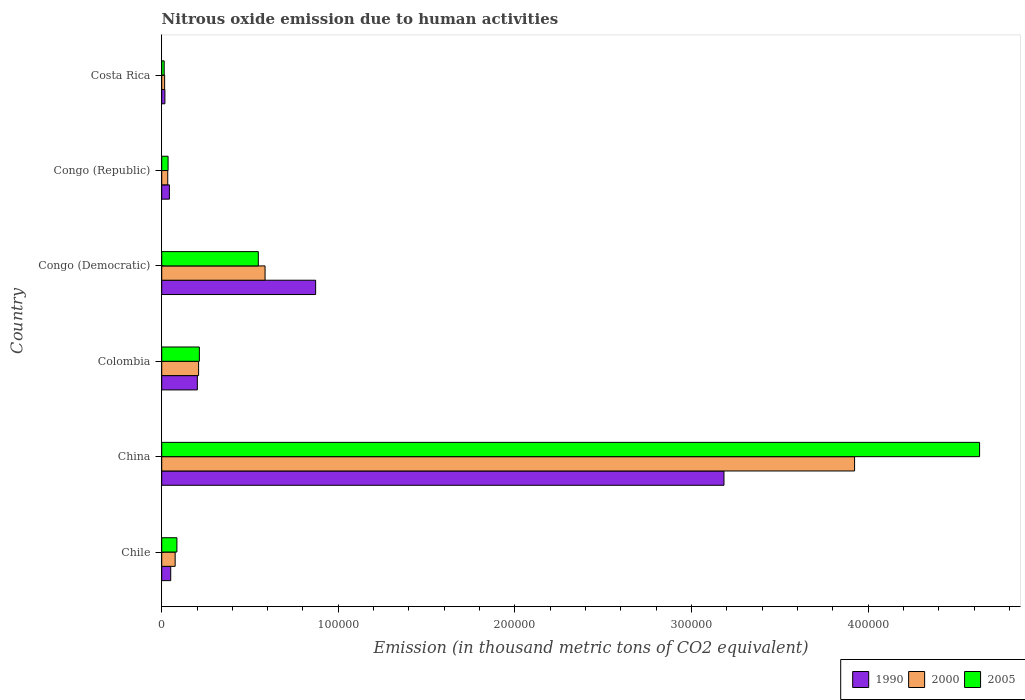How many groups of bars are there?
Make the answer very short. 6. Are the number of bars per tick equal to the number of legend labels?
Offer a very short reply. Yes. Are the number of bars on each tick of the Y-axis equal?
Offer a very short reply. Yes. How many bars are there on the 5th tick from the top?
Ensure brevity in your answer.  3. How many bars are there on the 6th tick from the bottom?
Give a very brief answer. 3. What is the amount of nitrous oxide emitted in 2005 in Colombia?
Your response must be concise. 2.13e+04. Across all countries, what is the maximum amount of nitrous oxide emitted in 1990?
Make the answer very short. 3.18e+05. Across all countries, what is the minimum amount of nitrous oxide emitted in 1990?
Your answer should be very brief. 1812.5. In which country was the amount of nitrous oxide emitted in 1990 maximum?
Give a very brief answer. China. What is the total amount of nitrous oxide emitted in 2000 in the graph?
Provide a succinct answer. 4.84e+05. What is the difference between the amount of nitrous oxide emitted in 2000 in Congo (Democratic) and that in Congo (Republic)?
Your answer should be very brief. 5.51e+04. What is the difference between the amount of nitrous oxide emitted in 1990 in Chile and the amount of nitrous oxide emitted in 2000 in Costa Rica?
Give a very brief answer. 3447.5. What is the average amount of nitrous oxide emitted in 1990 per country?
Make the answer very short. 7.28e+04. What is the difference between the amount of nitrous oxide emitted in 2000 and amount of nitrous oxide emitted in 1990 in Colombia?
Ensure brevity in your answer.  706.7. What is the ratio of the amount of nitrous oxide emitted in 1990 in Colombia to that in Costa Rica?
Offer a terse response. 11.13. Is the difference between the amount of nitrous oxide emitted in 2000 in China and Congo (Republic) greater than the difference between the amount of nitrous oxide emitted in 1990 in China and Congo (Republic)?
Your response must be concise. Yes. What is the difference between the highest and the second highest amount of nitrous oxide emitted in 2005?
Provide a short and direct response. 4.08e+05. What is the difference between the highest and the lowest amount of nitrous oxide emitted in 2000?
Your answer should be very brief. 3.91e+05. In how many countries, is the amount of nitrous oxide emitted in 2000 greater than the average amount of nitrous oxide emitted in 2000 taken over all countries?
Your response must be concise. 1. Is the sum of the amount of nitrous oxide emitted in 2000 in Chile and Congo (Democratic) greater than the maximum amount of nitrous oxide emitted in 1990 across all countries?
Provide a succinct answer. No. Is it the case that in every country, the sum of the amount of nitrous oxide emitted in 2000 and amount of nitrous oxide emitted in 1990 is greater than the amount of nitrous oxide emitted in 2005?
Offer a terse response. Yes. Are the values on the major ticks of X-axis written in scientific E-notation?
Provide a succinct answer. No. Does the graph contain any zero values?
Make the answer very short. No. Does the graph contain grids?
Give a very brief answer. No. How are the legend labels stacked?
Provide a succinct answer. Horizontal. What is the title of the graph?
Your answer should be very brief. Nitrous oxide emission due to human activities. What is the label or title of the X-axis?
Ensure brevity in your answer.  Emission (in thousand metric tons of CO2 equivalent). What is the label or title of the Y-axis?
Keep it short and to the point. Country. What is the Emission (in thousand metric tons of CO2 equivalent) of 1990 in Chile?
Keep it short and to the point. 5100.7. What is the Emission (in thousand metric tons of CO2 equivalent) of 2000 in Chile?
Give a very brief answer. 7617.9. What is the Emission (in thousand metric tons of CO2 equivalent) of 2005 in Chile?
Your answer should be very brief. 8607.6. What is the Emission (in thousand metric tons of CO2 equivalent) in 1990 in China?
Your answer should be compact. 3.18e+05. What is the Emission (in thousand metric tons of CO2 equivalent) in 2000 in China?
Provide a short and direct response. 3.92e+05. What is the Emission (in thousand metric tons of CO2 equivalent) of 2005 in China?
Give a very brief answer. 4.63e+05. What is the Emission (in thousand metric tons of CO2 equivalent) in 1990 in Colombia?
Your answer should be compact. 2.02e+04. What is the Emission (in thousand metric tons of CO2 equivalent) of 2000 in Colombia?
Offer a very short reply. 2.09e+04. What is the Emission (in thousand metric tons of CO2 equivalent) of 2005 in Colombia?
Keep it short and to the point. 2.13e+04. What is the Emission (in thousand metric tons of CO2 equivalent) of 1990 in Congo (Democratic)?
Make the answer very short. 8.72e+04. What is the Emission (in thousand metric tons of CO2 equivalent) of 2000 in Congo (Democratic)?
Offer a very short reply. 5.85e+04. What is the Emission (in thousand metric tons of CO2 equivalent) in 2005 in Congo (Democratic)?
Provide a succinct answer. 5.47e+04. What is the Emission (in thousand metric tons of CO2 equivalent) of 1990 in Congo (Republic)?
Your answer should be compact. 4351.5. What is the Emission (in thousand metric tons of CO2 equivalent) of 2000 in Congo (Republic)?
Your answer should be compact. 3418.3. What is the Emission (in thousand metric tons of CO2 equivalent) in 2005 in Congo (Republic)?
Ensure brevity in your answer.  3603.5. What is the Emission (in thousand metric tons of CO2 equivalent) in 1990 in Costa Rica?
Give a very brief answer. 1812.5. What is the Emission (in thousand metric tons of CO2 equivalent) in 2000 in Costa Rica?
Offer a terse response. 1653.2. What is the Emission (in thousand metric tons of CO2 equivalent) of 2005 in Costa Rica?
Offer a terse response. 1401. Across all countries, what is the maximum Emission (in thousand metric tons of CO2 equivalent) in 1990?
Make the answer very short. 3.18e+05. Across all countries, what is the maximum Emission (in thousand metric tons of CO2 equivalent) of 2000?
Your answer should be compact. 3.92e+05. Across all countries, what is the maximum Emission (in thousand metric tons of CO2 equivalent) in 2005?
Your answer should be compact. 4.63e+05. Across all countries, what is the minimum Emission (in thousand metric tons of CO2 equivalent) of 1990?
Provide a succinct answer. 1812.5. Across all countries, what is the minimum Emission (in thousand metric tons of CO2 equivalent) of 2000?
Your answer should be very brief. 1653.2. Across all countries, what is the minimum Emission (in thousand metric tons of CO2 equivalent) of 2005?
Keep it short and to the point. 1401. What is the total Emission (in thousand metric tons of CO2 equivalent) in 1990 in the graph?
Offer a terse response. 4.37e+05. What is the total Emission (in thousand metric tons of CO2 equivalent) in 2000 in the graph?
Offer a terse response. 4.84e+05. What is the total Emission (in thousand metric tons of CO2 equivalent) in 2005 in the graph?
Your answer should be very brief. 5.53e+05. What is the difference between the Emission (in thousand metric tons of CO2 equivalent) of 1990 in Chile and that in China?
Your answer should be compact. -3.13e+05. What is the difference between the Emission (in thousand metric tons of CO2 equivalent) in 2000 in Chile and that in China?
Give a very brief answer. -3.85e+05. What is the difference between the Emission (in thousand metric tons of CO2 equivalent) of 2005 in Chile and that in China?
Keep it short and to the point. -4.55e+05. What is the difference between the Emission (in thousand metric tons of CO2 equivalent) in 1990 in Chile and that in Colombia?
Offer a very short reply. -1.51e+04. What is the difference between the Emission (in thousand metric tons of CO2 equivalent) in 2000 in Chile and that in Colombia?
Offer a very short reply. -1.33e+04. What is the difference between the Emission (in thousand metric tons of CO2 equivalent) of 2005 in Chile and that in Colombia?
Provide a succinct answer. -1.27e+04. What is the difference between the Emission (in thousand metric tons of CO2 equivalent) of 1990 in Chile and that in Congo (Democratic)?
Ensure brevity in your answer.  -8.21e+04. What is the difference between the Emission (in thousand metric tons of CO2 equivalent) of 2000 in Chile and that in Congo (Democratic)?
Provide a short and direct response. -5.09e+04. What is the difference between the Emission (in thousand metric tons of CO2 equivalent) in 2005 in Chile and that in Congo (Democratic)?
Make the answer very short. -4.61e+04. What is the difference between the Emission (in thousand metric tons of CO2 equivalent) in 1990 in Chile and that in Congo (Republic)?
Provide a short and direct response. 749.2. What is the difference between the Emission (in thousand metric tons of CO2 equivalent) in 2000 in Chile and that in Congo (Republic)?
Offer a terse response. 4199.6. What is the difference between the Emission (in thousand metric tons of CO2 equivalent) of 2005 in Chile and that in Congo (Republic)?
Make the answer very short. 5004.1. What is the difference between the Emission (in thousand metric tons of CO2 equivalent) of 1990 in Chile and that in Costa Rica?
Ensure brevity in your answer.  3288.2. What is the difference between the Emission (in thousand metric tons of CO2 equivalent) of 2000 in Chile and that in Costa Rica?
Give a very brief answer. 5964.7. What is the difference between the Emission (in thousand metric tons of CO2 equivalent) in 2005 in Chile and that in Costa Rica?
Offer a very short reply. 7206.6. What is the difference between the Emission (in thousand metric tons of CO2 equivalent) in 1990 in China and that in Colombia?
Keep it short and to the point. 2.98e+05. What is the difference between the Emission (in thousand metric tons of CO2 equivalent) in 2000 in China and that in Colombia?
Provide a short and direct response. 3.71e+05. What is the difference between the Emission (in thousand metric tons of CO2 equivalent) of 2005 in China and that in Colombia?
Your response must be concise. 4.42e+05. What is the difference between the Emission (in thousand metric tons of CO2 equivalent) in 1990 in China and that in Congo (Democratic)?
Offer a terse response. 2.31e+05. What is the difference between the Emission (in thousand metric tons of CO2 equivalent) of 2000 in China and that in Congo (Democratic)?
Make the answer very short. 3.34e+05. What is the difference between the Emission (in thousand metric tons of CO2 equivalent) of 2005 in China and that in Congo (Democratic)?
Make the answer very short. 4.08e+05. What is the difference between the Emission (in thousand metric tons of CO2 equivalent) in 1990 in China and that in Congo (Republic)?
Provide a short and direct response. 3.14e+05. What is the difference between the Emission (in thousand metric tons of CO2 equivalent) of 2000 in China and that in Congo (Republic)?
Offer a terse response. 3.89e+05. What is the difference between the Emission (in thousand metric tons of CO2 equivalent) in 2005 in China and that in Congo (Republic)?
Offer a very short reply. 4.60e+05. What is the difference between the Emission (in thousand metric tons of CO2 equivalent) in 1990 in China and that in Costa Rica?
Give a very brief answer. 3.17e+05. What is the difference between the Emission (in thousand metric tons of CO2 equivalent) in 2000 in China and that in Costa Rica?
Keep it short and to the point. 3.91e+05. What is the difference between the Emission (in thousand metric tons of CO2 equivalent) in 2005 in China and that in Costa Rica?
Ensure brevity in your answer.  4.62e+05. What is the difference between the Emission (in thousand metric tons of CO2 equivalent) in 1990 in Colombia and that in Congo (Democratic)?
Your answer should be very brief. -6.70e+04. What is the difference between the Emission (in thousand metric tons of CO2 equivalent) of 2000 in Colombia and that in Congo (Democratic)?
Make the answer very short. -3.76e+04. What is the difference between the Emission (in thousand metric tons of CO2 equivalent) of 2005 in Colombia and that in Congo (Democratic)?
Offer a terse response. -3.34e+04. What is the difference between the Emission (in thousand metric tons of CO2 equivalent) in 1990 in Colombia and that in Congo (Republic)?
Keep it short and to the point. 1.58e+04. What is the difference between the Emission (in thousand metric tons of CO2 equivalent) in 2000 in Colombia and that in Congo (Republic)?
Keep it short and to the point. 1.75e+04. What is the difference between the Emission (in thousand metric tons of CO2 equivalent) of 2005 in Colombia and that in Congo (Republic)?
Ensure brevity in your answer.  1.77e+04. What is the difference between the Emission (in thousand metric tons of CO2 equivalent) in 1990 in Colombia and that in Costa Rica?
Keep it short and to the point. 1.84e+04. What is the difference between the Emission (in thousand metric tons of CO2 equivalent) of 2000 in Colombia and that in Costa Rica?
Provide a succinct answer. 1.92e+04. What is the difference between the Emission (in thousand metric tons of CO2 equivalent) of 2005 in Colombia and that in Costa Rica?
Provide a succinct answer. 1.99e+04. What is the difference between the Emission (in thousand metric tons of CO2 equivalent) in 1990 in Congo (Democratic) and that in Congo (Republic)?
Provide a short and direct response. 8.28e+04. What is the difference between the Emission (in thousand metric tons of CO2 equivalent) in 2000 in Congo (Democratic) and that in Congo (Republic)?
Make the answer very short. 5.51e+04. What is the difference between the Emission (in thousand metric tons of CO2 equivalent) of 2005 in Congo (Democratic) and that in Congo (Republic)?
Make the answer very short. 5.11e+04. What is the difference between the Emission (in thousand metric tons of CO2 equivalent) in 1990 in Congo (Democratic) and that in Costa Rica?
Offer a very short reply. 8.54e+04. What is the difference between the Emission (in thousand metric tons of CO2 equivalent) in 2000 in Congo (Democratic) and that in Costa Rica?
Provide a succinct answer. 5.69e+04. What is the difference between the Emission (in thousand metric tons of CO2 equivalent) in 2005 in Congo (Democratic) and that in Costa Rica?
Offer a terse response. 5.33e+04. What is the difference between the Emission (in thousand metric tons of CO2 equivalent) of 1990 in Congo (Republic) and that in Costa Rica?
Offer a very short reply. 2539. What is the difference between the Emission (in thousand metric tons of CO2 equivalent) of 2000 in Congo (Republic) and that in Costa Rica?
Your answer should be compact. 1765.1. What is the difference between the Emission (in thousand metric tons of CO2 equivalent) in 2005 in Congo (Republic) and that in Costa Rica?
Make the answer very short. 2202.5. What is the difference between the Emission (in thousand metric tons of CO2 equivalent) of 1990 in Chile and the Emission (in thousand metric tons of CO2 equivalent) of 2000 in China?
Provide a short and direct response. -3.87e+05. What is the difference between the Emission (in thousand metric tons of CO2 equivalent) in 1990 in Chile and the Emission (in thousand metric tons of CO2 equivalent) in 2005 in China?
Your response must be concise. -4.58e+05. What is the difference between the Emission (in thousand metric tons of CO2 equivalent) in 2000 in Chile and the Emission (in thousand metric tons of CO2 equivalent) in 2005 in China?
Offer a terse response. -4.56e+05. What is the difference between the Emission (in thousand metric tons of CO2 equivalent) in 1990 in Chile and the Emission (in thousand metric tons of CO2 equivalent) in 2000 in Colombia?
Offer a terse response. -1.58e+04. What is the difference between the Emission (in thousand metric tons of CO2 equivalent) of 1990 in Chile and the Emission (in thousand metric tons of CO2 equivalent) of 2005 in Colombia?
Provide a short and direct response. -1.62e+04. What is the difference between the Emission (in thousand metric tons of CO2 equivalent) in 2000 in Chile and the Emission (in thousand metric tons of CO2 equivalent) in 2005 in Colombia?
Make the answer very short. -1.37e+04. What is the difference between the Emission (in thousand metric tons of CO2 equivalent) of 1990 in Chile and the Emission (in thousand metric tons of CO2 equivalent) of 2000 in Congo (Democratic)?
Your answer should be compact. -5.34e+04. What is the difference between the Emission (in thousand metric tons of CO2 equivalent) in 1990 in Chile and the Emission (in thousand metric tons of CO2 equivalent) in 2005 in Congo (Democratic)?
Provide a short and direct response. -4.96e+04. What is the difference between the Emission (in thousand metric tons of CO2 equivalent) in 2000 in Chile and the Emission (in thousand metric tons of CO2 equivalent) in 2005 in Congo (Democratic)?
Your answer should be very brief. -4.71e+04. What is the difference between the Emission (in thousand metric tons of CO2 equivalent) in 1990 in Chile and the Emission (in thousand metric tons of CO2 equivalent) in 2000 in Congo (Republic)?
Give a very brief answer. 1682.4. What is the difference between the Emission (in thousand metric tons of CO2 equivalent) of 1990 in Chile and the Emission (in thousand metric tons of CO2 equivalent) of 2005 in Congo (Republic)?
Provide a short and direct response. 1497.2. What is the difference between the Emission (in thousand metric tons of CO2 equivalent) in 2000 in Chile and the Emission (in thousand metric tons of CO2 equivalent) in 2005 in Congo (Republic)?
Provide a succinct answer. 4014.4. What is the difference between the Emission (in thousand metric tons of CO2 equivalent) of 1990 in Chile and the Emission (in thousand metric tons of CO2 equivalent) of 2000 in Costa Rica?
Offer a very short reply. 3447.5. What is the difference between the Emission (in thousand metric tons of CO2 equivalent) of 1990 in Chile and the Emission (in thousand metric tons of CO2 equivalent) of 2005 in Costa Rica?
Provide a short and direct response. 3699.7. What is the difference between the Emission (in thousand metric tons of CO2 equivalent) in 2000 in Chile and the Emission (in thousand metric tons of CO2 equivalent) in 2005 in Costa Rica?
Your answer should be compact. 6216.9. What is the difference between the Emission (in thousand metric tons of CO2 equivalent) of 1990 in China and the Emission (in thousand metric tons of CO2 equivalent) of 2000 in Colombia?
Your answer should be compact. 2.98e+05. What is the difference between the Emission (in thousand metric tons of CO2 equivalent) in 1990 in China and the Emission (in thousand metric tons of CO2 equivalent) in 2005 in Colombia?
Offer a very short reply. 2.97e+05. What is the difference between the Emission (in thousand metric tons of CO2 equivalent) in 2000 in China and the Emission (in thousand metric tons of CO2 equivalent) in 2005 in Colombia?
Provide a short and direct response. 3.71e+05. What is the difference between the Emission (in thousand metric tons of CO2 equivalent) in 1990 in China and the Emission (in thousand metric tons of CO2 equivalent) in 2000 in Congo (Democratic)?
Offer a very short reply. 2.60e+05. What is the difference between the Emission (in thousand metric tons of CO2 equivalent) in 1990 in China and the Emission (in thousand metric tons of CO2 equivalent) in 2005 in Congo (Democratic)?
Ensure brevity in your answer.  2.64e+05. What is the difference between the Emission (in thousand metric tons of CO2 equivalent) in 2000 in China and the Emission (in thousand metric tons of CO2 equivalent) in 2005 in Congo (Democratic)?
Offer a very short reply. 3.38e+05. What is the difference between the Emission (in thousand metric tons of CO2 equivalent) in 1990 in China and the Emission (in thousand metric tons of CO2 equivalent) in 2000 in Congo (Republic)?
Offer a very short reply. 3.15e+05. What is the difference between the Emission (in thousand metric tons of CO2 equivalent) in 1990 in China and the Emission (in thousand metric tons of CO2 equivalent) in 2005 in Congo (Republic)?
Offer a terse response. 3.15e+05. What is the difference between the Emission (in thousand metric tons of CO2 equivalent) of 2000 in China and the Emission (in thousand metric tons of CO2 equivalent) of 2005 in Congo (Republic)?
Your response must be concise. 3.89e+05. What is the difference between the Emission (in thousand metric tons of CO2 equivalent) in 1990 in China and the Emission (in thousand metric tons of CO2 equivalent) in 2000 in Costa Rica?
Give a very brief answer. 3.17e+05. What is the difference between the Emission (in thousand metric tons of CO2 equivalent) in 1990 in China and the Emission (in thousand metric tons of CO2 equivalent) in 2005 in Costa Rica?
Provide a short and direct response. 3.17e+05. What is the difference between the Emission (in thousand metric tons of CO2 equivalent) of 2000 in China and the Emission (in thousand metric tons of CO2 equivalent) of 2005 in Costa Rica?
Your answer should be compact. 3.91e+05. What is the difference between the Emission (in thousand metric tons of CO2 equivalent) in 1990 in Colombia and the Emission (in thousand metric tons of CO2 equivalent) in 2000 in Congo (Democratic)?
Your response must be concise. -3.83e+04. What is the difference between the Emission (in thousand metric tons of CO2 equivalent) in 1990 in Colombia and the Emission (in thousand metric tons of CO2 equivalent) in 2005 in Congo (Democratic)?
Ensure brevity in your answer.  -3.45e+04. What is the difference between the Emission (in thousand metric tons of CO2 equivalent) in 2000 in Colombia and the Emission (in thousand metric tons of CO2 equivalent) in 2005 in Congo (Democratic)?
Offer a very short reply. -3.38e+04. What is the difference between the Emission (in thousand metric tons of CO2 equivalent) in 1990 in Colombia and the Emission (in thousand metric tons of CO2 equivalent) in 2000 in Congo (Republic)?
Offer a very short reply. 1.68e+04. What is the difference between the Emission (in thousand metric tons of CO2 equivalent) in 1990 in Colombia and the Emission (in thousand metric tons of CO2 equivalent) in 2005 in Congo (Republic)?
Your answer should be compact. 1.66e+04. What is the difference between the Emission (in thousand metric tons of CO2 equivalent) of 2000 in Colombia and the Emission (in thousand metric tons of CO2 equivalent) of 2005 in Congo (Republic)?
Your answer should be very brief. 1.73e+04. What is the difference between the Emission (in thousand metric tons of CO2 equivalent) in 1990 in Colombia and the Emission (in thousand metric tons of CO2 equivalent) in 2000 in Costa Rica?
Offer a very short reply. 1.85e+04. What is the difference between the Emission (in thousand metric tons of CO2 equivalent) of 1990 in Colombia and the Emission (in thousand metric tons of CO2 equivalent) of 2005 in Costa Rica?
Your response must be concise. 1.88e+04. What is the difference between the Emission (in thousand metric tons of CO2 equivalent) of 2000 in Colombia and the Emission (in thousand metric tons of CO2 equivalent) of 2005 in Costa Rica?
Keep it short and to the point. 1.95e+04. What is the difference between the Emission (in thousand metric tons of CO2 equivalent) of 1990 in Congo (Democratic) and the Emission (in thousand metric tons of CO2 equivalent) of 2000 in Congo (Republic)?
Offer a very short reply. 8.37e+04. What is the difference between the Emission (in thousand metric tons of CO2 equivalent) in 1990 in Congo (Democratic) and the Emission (in thousand metric tons of CO2 equivalent) in 2005 in Congo (Republic)?
Your response must be concise. 8.36e+04. What is the difference between the Emission (in thousand metric tons of CO2 equivalent) in 2000 in Congo (Democratic) and the Emission (in thousand metric tons of CO2 equivalent) in 2005 in Congo (Republic)?
Provide a short and direct response. 5.49e+04. What is the difference between the Emission (in thousand metric tons of CO2 equivalent) in 1990 in Congo (Democratic) and the Emission (in thousand metric tons of CO2 equivalent) in 2000 in Costa Rica?
Give a very brief answer. 8.55e+04. What is the difference between the Emission (in thousand metric tons of CO2 equivalent) of 1990 in Congo (Democratic) and the Emission (in thousand metric tons of CO2 equivalent) of 2005 in Costa Rica?
Give a very brief answer. 8.58e+04. What is the difference between the Emission (in thousand metric tons of CO2 equivalent) of 2000 in Congo (Democratic) and the Emission (in thousand metric tons of CO2 equivalent) of 2005 in Costa Rica?
Your answer should be compact. 5.71e+04. What is the difference between the Emission (in thousand metric tons of CO2 equivalent) in 1990 in Congo (Republic) and the Emission (in thousand metric tons of CO2 equivalent) in 2000 in Costa Rica?
Keep it short and to the point. 2698.3. What is the difference between the Emission (in thousand metric tons of CO2 equivalent) in 1990 in Congo (Republic) and the Emission (in thousand metric tons of CO2 equivalent) in 2005 in Costa Rica?
Offer a terse response. 2950.5. What is the difference between the Emission (in thousand metric tons of CO2 equivalent) of 2000 in Congo (Republic) and the Emission (in thousand metric tons of CO2 equivalent) of 2005 in Costa Rica?
Offer a terse response. 2017.3. What is the average Emission (in thousand metric tons of CO2 equivalent) of 1990 per country?
Make the answer very short. 7.28e+04. What is the average Emission (in thousand metric tons of CO2 equivalent) in 2000 per country?
Your answer should be very brief. 8.07e+04. What is the average Emission (in thousand metric tons of CO2 equivalent) in 2005 per country?
Provide a succinct answer. 9.21e+04. What is the difference between the Emission (in thousand metric tons of CO2 equivalent) in 1990 and Emission (in thousand metric tons of CO2 equivalent) in 2000 in Chile?
Ensure brevity in your answer.  -2517.2. What is the difference between the Emission (in thousand metric tons of CO2 equivalent) of 1990 and Emission (in thousand metric tons of CO2 equivalent) of 2005 in Chile?
Your answer should be very brief. -3506.9. What is the difference between the Emission (in thousand metric tons of CO2 equivalent) in 2000 and Emission (in thousand metric tons of CO2 equivalent) in 2005 in Chile?
Make the answer very short. -989.7. What is the difference between the Emission (in thousand metric tons of CO2 equivalent) in 1990 and Emission (in thousand metric tons of CO2 equivalent) in 2000 in China?
Give a very brief answer. -7.40e+04. What is the difference between the Emission (in thousand metric tons of CO2 equivalent) in 1990 and Emission (in thousand metric tons of CO2 equivalent) in 2005 in China?
Your answer should be compact. -1.45e+05. What is the difference between the Emission (in thousand metric tons of CO2 equivalent) of 2000 and Emission (in thousand metric tons of CO2 equivalent) of 2005 in China?
Provide a succinct answer. -7.08e+04. What is the difference between the Emission (in thousand metric tons of CO2 equivalent) in 1990 and Emission (in thousand metric tons of CO2 equivalent) in 2000 in Colombia?
Your response must be concise. -706.7. What is the difference between the Emission (in thousand metric tons of CO2 equivalent) in 1990 and Emission (in thousand metric tons of CO2 equivalent) in 2005 in Colombia?
Provide a succinct answer. -1134.8. What is the difference between the Emission (in thousand metric tons of CO2 equivalent) in 2000 and Emission (in thousand metric tons of CO2 equivalent) in 2005 in Colombia?
Offer a very short reply. -428.1. What is the difference between the Emission (in thousand metric tons of CO2 equivalent) of 1990 and Emission (in thousand metric tons of CO2 equivalent) of 2000 in Congo (Democratic)?
Give a very brief answer. 2.86e+04. What is the difference between the Emission (in thousand metric tons of CO2 equivalent) in 1990 and Emission (in thousand metric tons of CO2 equivalent) in 2005 in Congo (Democratic)?
Make the answer very short. 3.25e+04. What is the difference between the Emission (in thousand metric tons of CO2 equivalent) of 2000 and Emission (in thousand metric tons of CO2 equivalent) of 2005 in Congo (Democratic)?
Keep it short and to the point. 3826.5. What is the difference between the Emission (in thousand metric tons of CO2 equivalent) of 1990 and Emission (in thousand metric tons of CO2 equivalent) of 2000 in Congo (Republic)?
Provide a succinct answer. 933.2. What is the difference between the Emission (in thousand metric tons of CO2 equivalent) in 1990 and Emission (in thousand metric tons of CO2 equivalent) in 2005 in Congo (Republic)?
Your answer should be very brief. 748. What is the difference between the Emission (in thousand metric tons of CO2 equivalent) in 2000 and Emission (in thousand metric tons of CO2 equivalent) in 2005 in Congo (Republic)?
Ensure brevity in your answer.  -185.2. What is the difference between the Emission (in thousand metric tons of CO2 equivalent) in 1990 and Emission (in thousand metric tons of CO2 equivalent) in 2000 in Costa Rica?
Offer a terse response. 159.3. What is the difference between the Emission (in thousand metric tons of CO2 equivalent) in 1990 and Emission (in thousand metric tons of CO2 equivalent) in 2005 in Costa Rica?
Ensure brevity in your answer.  411.5. What is the difference between the Emission (in thousand metric tons of CO2 equivalent) in 2000 and Emission (in thousand metric tons of CO2 equivalent) in 2005 in Costa Rica?
Your answer should be very brief. 252.2. What is the ratio of the Emission (in thousand metric tons of CO2 equivalent) in 1990 in Chile to that in China?
Ensure brevity in your answer.  0.02. What is the ratio of the Emission (in thousand metric tons of CO2 equivalent) of 2000 in Chile to that in China?
Your response must be concise. 0.02. What is the ratio of the Emission (in thousand metric tons of CO2 equivalent) in 2005 in Chile to that in China?
Your response must be concise. 0.02. What is the ratio of the Emission (in thousand metric tons of CO2 equivalent) in 1990 in Chile to that in Colombia?
Keep it short and to the point. 0.25. What is the ratio of the Emission (in thousand metric tons of CO2 equivalent) of 2000 in Chile to that in Colombia?
Provide a succinct answer. 0.36. What is the ratio of the Emission (in thousand metric tons of CO2 equivalent) in 2005 in Chile to that in Colombia?
Ensure brevity in your answer.  0.4. What is the ratio of the Emission (in thousand metric tons of CO2 equivalent) of 1990 in Chile to that in Congo (Democratic)?
Provide a succinct answer. 0.06. What is the ratio of the Emission (in thousand metric tons of CO2 equivalent) in 2000 in Chile to that in Congo (Democratic)?
Provide a short and direct response. 0.13. What is the ratio of the Emission (in thousand metric tons of CO2 equivalent) in 2005 in Chile to that in Congo (Democratic)?
Provide a succinct answer. 0.16. What is the ratio of the Emission (in thousand metric tons of CO2 equivalent) of 1990 in Chile to that in Congo (Republic)?
Make the answer very short. 1.17. What is the ratio of the Emission (in thousand metric tons of CO2 equivalent) of 2000 in Chile to that in Congo (Republic)?
Ensure brevity in your answer.  2.23. What is the ratio of the Emission (in thousand metric tons of CO2 equivalent) in 2005 in Chile to that in Congo (Republic)?
Ensure brevity in your answer.  2.39. What is the ratio of the Emission (in thousand metric tons of CO2 equivalent) in 1990 in Chile to that in Costa Rica?
Your response must be concise. 2.81. What is the ratio of the Emission (in thousand metric tons of CO2 equivalent) in 2000 in Chile to that in Costa Rica?
Provide a succinct answer. 4.61. What is the ratio of the Emission (in thousand metric tons of CO2 equivalent) in 2005 in Chile to that in Costa Rica?
Make the answer very short. 6.14. What is the ratio of the Emission (in thousand metric tons of CO2 equivalent) of 1990 in China to that in Colombia?
Keep it short and to the point. 15.78. What is the ratio of the Emission (in thousand metric tons of CO2 equivalent) of 2000 in China to that in Colombia?
Offer a very short reply. 18.78. What is the ratio of the Emission (in thousand metric tons of CO2 equivalent) in 2005 in China to that in Colombia?
Give a very brief answer. 21.73. What is the ratio of the Emission (in thousand metric tons of CO2 equivalent) in 1990 in China to that in Congo (Democratic)?
Make the answer very short. 3.65. What is the ratio of the Emission (in thousand metric tons of CO2 equivalent) of 2000 in China to that in Congo (Democratic)?
Provide a succinct answer. 6.7. What is the ratio of the Emission (in thousand metric tons of CO2 equivalent) in 2005 in China to that in Congo (Democratic)?
Your answer should be very brief. 8.47. What is the ratio of the Emission (in thousand metric tons of CO2 equivalent) in 1990 in China to that in Congo (Republic)?
Your answer should be very brief. 73.17. What is the ratio of the Emission (in thousand metric tons of CO2 equivalent) of 2000 in China to that in Congo (Republic)?
Keep it short and to the point. 114.78. What is the ratio of the Emission (in thousand metric tons of CO2 equivalent) in 2005 in China to that in Congo (Republic)?
Your response must be concise. 128.53. What is the ratio of the Emission (in thousand metric tons of CO2 equivalent) of 1990 in China to that in Costa Rica?
Provide a succinct answer. 175.67. What is the ratio of the Emission (in thousand metric tons of CO2 equivalent) in 2000 in China to that in Costa Rica?
Give a very brief answer. 237.34. What is the ratio of the Emission (in thousand metric tons of CO2 equivalent) in 2005 in China to that in Costa Rica?
Make the answer very short. 330.6. What is the ratio of the Emission (in thousand metric tons of CO2 equivalent) of 1990 in Colombia to that in Congo (Democratic)?
Make the answer very short. 0.23. What is the ratio of the Emission (in thousand metric tons of CO2 equivalent) of 2000 in Colombia to that in Congo (Democratic)?
Your answer should be compact. 0.36. What is the ratio of the Emission (in thousand metric tons of CO2 equivalent) in 2005 in Colombia to that in Congo (Democratic)?
Keep it short and to the point. 0.39. What is the ratio of the Emission (in thousand metric tons of CO2 equivalent) in 1990 in Colombia to that in Congo (Republic)?
Offer a terse response. 4.64. What is the ratio of the Emission (in thousand metric tons of CO2 equivalent) of 2000 in Colombia to that in Congo (Republic)?
Your response must be concise. 6.11. What is the ratio of the Emission (in thousand metric tons of CO2 equivalent) in 2005 in Colombia to that in Congo (Republic)?
Give a very brief answer. 5.92. What is the ratio of the Emission (in thousand metric tons of CO2 equivalent) of 1990 in Colombia to that in Costa Rica?
Make the answer very short. 11.13. What is the ratio of the Emission (in thousand metric tons of CO2 equivalent) of 2000 in Colombia to that in Costa Rica?
Your answer should be compact. 12.64. What is the ratio of the Emission (in thousand metric tons of CO2 equivalent) of 2005 in Colombia to that in Costa Rica?
Ensure brevity in your answer.  15.22. What is the ratio of the Emission (in thousand metric tons of CO2 equivalent) in 1990 in Congo (Democratic) to that in Congo (Republic)?
Make the answer very short. 20.03. What is the ratio of the Emission (in thousand metric tons of CO2 equivalent) in 2000 in Congo (Democratic) to that in Congo (Republic)?
Your answer should be compact. 17.12. What is the ratio of the Emission (in thousand metric tons of CO2 equivalent) in 2005 in Congo (Democratic) to that in Congo (Republic)?
Offer a very short reply. 15.18. What is the ratio of the Emission (in thousand metric tons of CO2 equivalent) of 1990 in Congo (Democratic) to that in Costa Rica?
Keep it short and to the point. 48.09. What is the ratio of the Emission (in thousand metric tons of CO2 equivalent) in 2000 in Congo (Democratic) to that in Costa Rica?
Your response must be concise. 35.4. What is the ratio of the Emission (in thousand metric tons of CO2 equivalent) of 2005 in Congo (Democratic) to that in Costa Rica?
Your answer should be compact. 39.04. What is the ratio of the Emission (in thousand metric tons of CO2 equivalent) in 1990 in Congo (Republic) to that in Costa Rica?
Make the answer very short. 2.4. What is the ratio of the Emission (in thousand metric tons of CO2 equivalent) of 2000 in Congo (Republic) to that in Costa Rica?
Make the answer very short. 2.07. What is the ratio of the Emission (in thousand metric tons of CO2 equivalent) in 2005 in Congo (Republic) to that in Costa Rica?
Offer a very short reply. 2.57. What is the difference between the highest and the second highest Emission (in thousand metric tons of CO2 equivalent) in 1990?
Your answer should be compact. 2.31e+05. What is the difference between the highest and the second highest Emission (in thousand metric tons of CO2 equivalent) of 2000?
Your response must be concise. 3.34e+05. What is the difference between the highest and the second highest Emission (in thousand metric tons of CO2 equivalent) of 2005?
Offer a very short reply. 4.08e+05. What is the difference between the highest and the lowest Emission (in thousand metric tons of CO2 equivalent) of 1990?
Offer a terse response. 3.17e+05. What is the difference between the highest and the lowest Emission (in thousand metric tons of CO2 equivalent) of 2000?
Your answer should be very brief. 3.91e+05. What is the difference between the highest and the lowest Emission (in thousand metric tons of CO2 equivalent) of 2005?
Provide a succinct answer. 4.62e+05. 